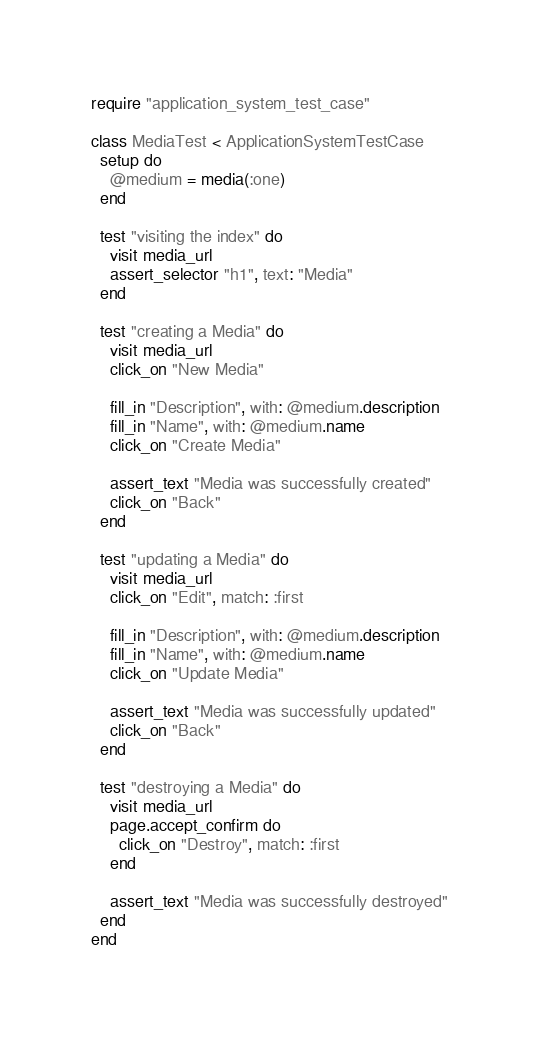<code> <loc_0><loc_0><loc_500><loc_500><_Ruby_>require "application_system_test_case"

class MediaTest < ApplicationSystemTestCase
  setup do
    @medium = media(:one)
  end

  test "visiting the index" do
    visit media_url
    assert_selector "h1", text: "Media"
  end

  test "creating a Media" do
    visit media_url
    click_on "New Media"

    fill_in "Description", with: @medium.description
    fill_in "Name", with: @medium.name
    click_on "Create Media"

    assert_text "Media was successfully created"
    click_on "Back"
  end

  test "updating a Media" do
    visit media_url
    click_on "Edit", match: :first

    fill_in "Description", with: @medium.description
    fill_in "Name", with: @medium.name
    click_on "Update Media"

    assert_text "Media was successfully updated"
    click_on "Back"
  end

  test "destroying a Media" do
    visit media_url
    page.accept_confirm do
      click_on "Destroy", match: :first
    end

    assert_text "Media was successfully destroyed"
  end
end
</code> 